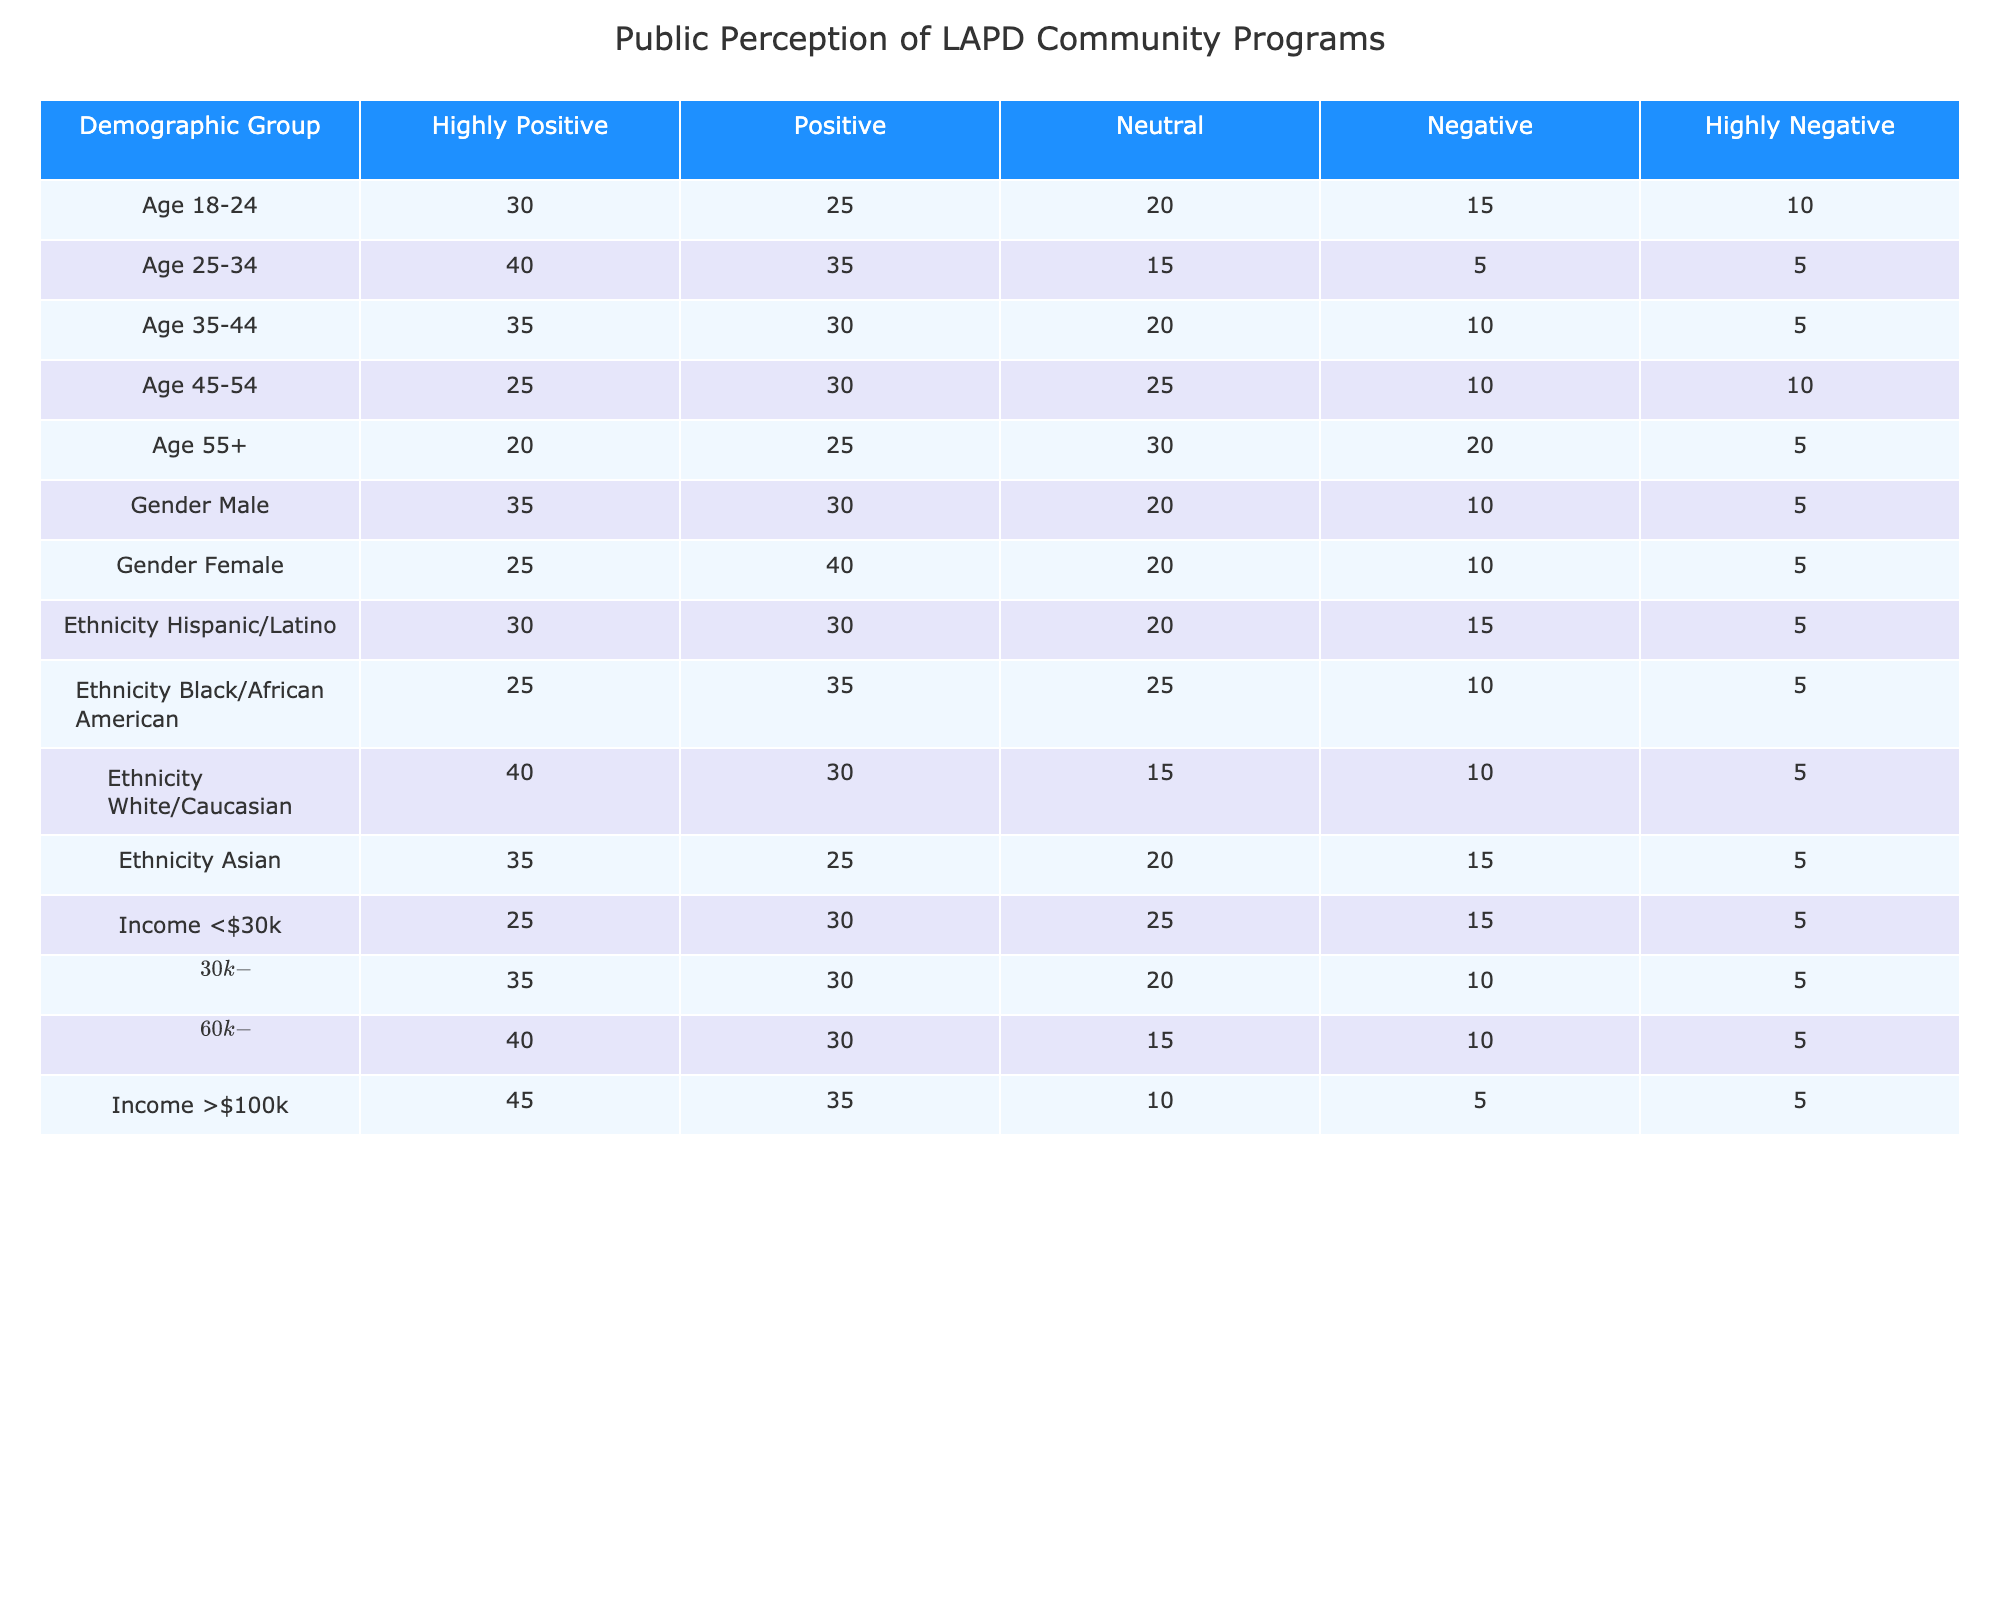What percentage of the Age 25-34 demographic had a 'Highly Positive' perception of LAPD's community programs? The table indicates that 40 individuals from the Age 25-34 group had a 'Highly Positive' perception. The total number of responses for this demographic is 40 + 35 + 15 + 5 + 5 = 100. To find the percentage, the formula is (40/100) * 100 = 40%.
Answer: 40% Which demographic group shows the highest 'Negative' perception of LAPD's community programs? For the 'Negative' category, we can look across the demographic groups. The Age 18-24 group had 15, Age 25-34 had 5, Age 35-44 had 10, Age 45-54 had 10, Age 55+ had 20; Gender Male had 10, Gender Female had 10; Ethnicity Hispanic/Latino had 15, Black/African American had 10, White/Caucasian had 10, Asian had 15; Income <$30k had 15, $30k-$60k had 10, $60k-$100k had 10, and >$100k had 5. The highest number for 'Negative' is seen in the Age 55+ group with 20.
Answer: Age 55+ What is the total count of 'Positive' perceptions across all Age groups? For the 'Positive' category, adding up all the numbers in this category provides the required total: 25 (Age 18-24) + 35 (Age 25-34) + 30 (Age 35-44) + 30 (Age 45-54) + 25 (Age 55+) = 175.
Answer: 175 Is it true that the Ethnicity group of Asian has a higher 'Highly Positive' perception compared to the Age group of 45-54? For the 'Highly Positive' perception, Asian has 35 while Age 45-54 has 25. Since 35 > 25, it is indeed true that the Asian demographic has a higher 'Highly Positive' response.
Answer: Yes What is the average number of 'Neutral' perceptions across all income groups? The 'Neutral' perceptions for each income group are as follows: 25 (<$30k), 20 ($30k-$60k), 15 ($60k-$100k), and 10 (> $100k). Adding these gives 25 + 20 + 15 + 10 = 70. To find the average, we divide by the number of groups, which is 4: 70/4 = 17.5.
Answer: 17.5 